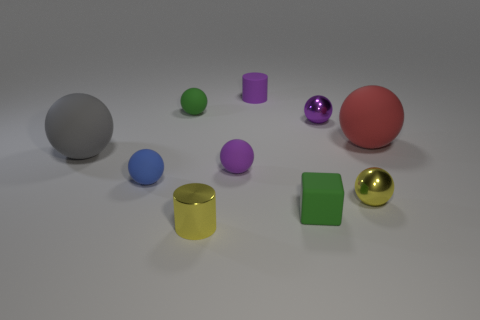There is a yellow object that is the same shape as the red rubber thing; what is its size?
Ensure brevity in your answer.  Small. There is a sphere that is both behind the large red thing and right of the green block; what is it made of?
Provide a succinct answer. Metal. Are there an equal number of yellow shiny things that are behind the tiny green rubber block and green rubber cubes?
Provide a succinct answer. Yes. How many things are either yellow objects that are to the left of the small green cube or tiny yellow shiny cylinders?
Keep it short and to the point. 1. Do the large rubber thing to the left of the yellow cylinder and the rubber cylinder have the same color?
Ensure brevity in your answer.  No. There is a green object that is behind the large red matte thing; how big is it?
Keep it short and to the point. Small. The shiny thing that is on the left side of the green matte thing in front of the large gray rubber thing is what shape?
Provide a short and direct response. Cylinder. What is the color of the other large rubber object that is the same shape as the big red rubber thing?
Offer a terse response. Gray. There is a blue matte thing that is in front of the purple matte sphere; does it have the same size as the big red thing?
Give a very brief answer. No. What is the shape of the metallic object that is the same color as the rubber cylinder?
Offer a terse response. Sphere. 